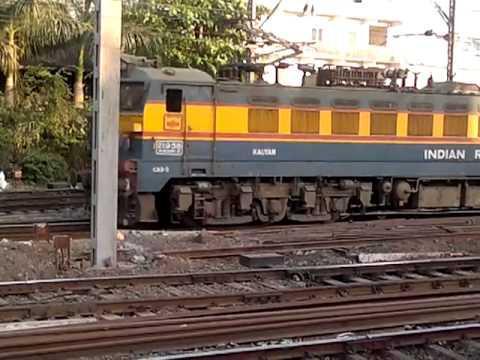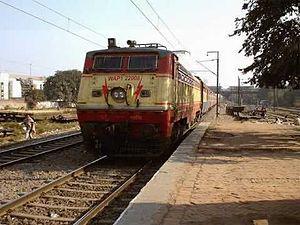The first image is the image on the left, the second image is the image on the right. For the images shown, is this caption "The top of one of the trains is blue." true? Answer yes or no. No. 